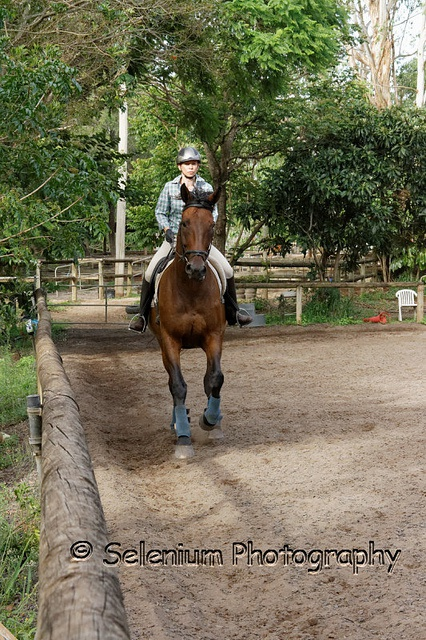Describe the objects in this image and their specific colors. I can see horse in olive, black, maroon, and gray tones, people in olive, black, lightgray, gray, and darkgray tones, and chair in olive, white, darkgray, and gray tones in this image. 